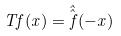<formula> <loc_0><loc_0><loc_500><loc_500>T f ( x ) = \hat { \hat { f } } ( - x )</formula> 